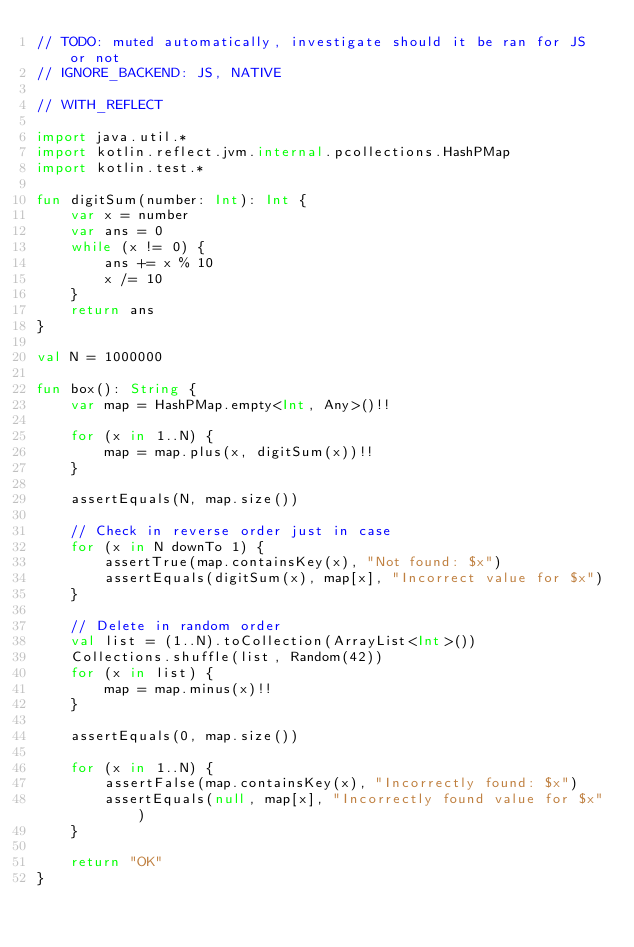Convert code to text. <code><loc_0><loc_0><loc_500><loc_500><_Kotlin_>// TODO: muted automatically, investigate should it be ran for JS or not
// IGNORE_BACKEND: JS, NATIVE

// WITH_REFLECT

import java.util.*
import kotlin.reflect.jvm.internal.pcollections.HashPMap
import kotlin.test.*

fun digitSum(number: Int): Int {
    var x = number
    var ans = 0
    while (x != 0) {
        ans += x % 10
        x /= 10
    }
    return ans
}

val N = 1000000

fun box(): String {
    var map = HashPMap.empty<Int, Any>()!!

    for (x in 1..N) {
        map = map.plus(x, digitSum(x))!!
    }

    assertEquals(N, map.size())
    
    // Check in reverse order just in case
    for (x in N downTo 1) {
        assertTrue(map.containsKey(x), "Not found: $x")
        assertEquals(digitSum(x), map[x], "Incorrect value for $x")
    }

    // Delete in random order
    val list = (1..N).toCollection(ArrayList<Int>())
    Collections.shuffle(list, Random(42))
    for (x in list) {
        map = map.minus(x)!!
    }

    assertEquals(0, map.size())

    for (x in 1..N) {
        assertFalse(map.containsKey(x), "Incorrectly found: $x")
        assertEquals(null, map[x], "Incorrectly found value for $x")
    }

    return "OK"
}
</code> 